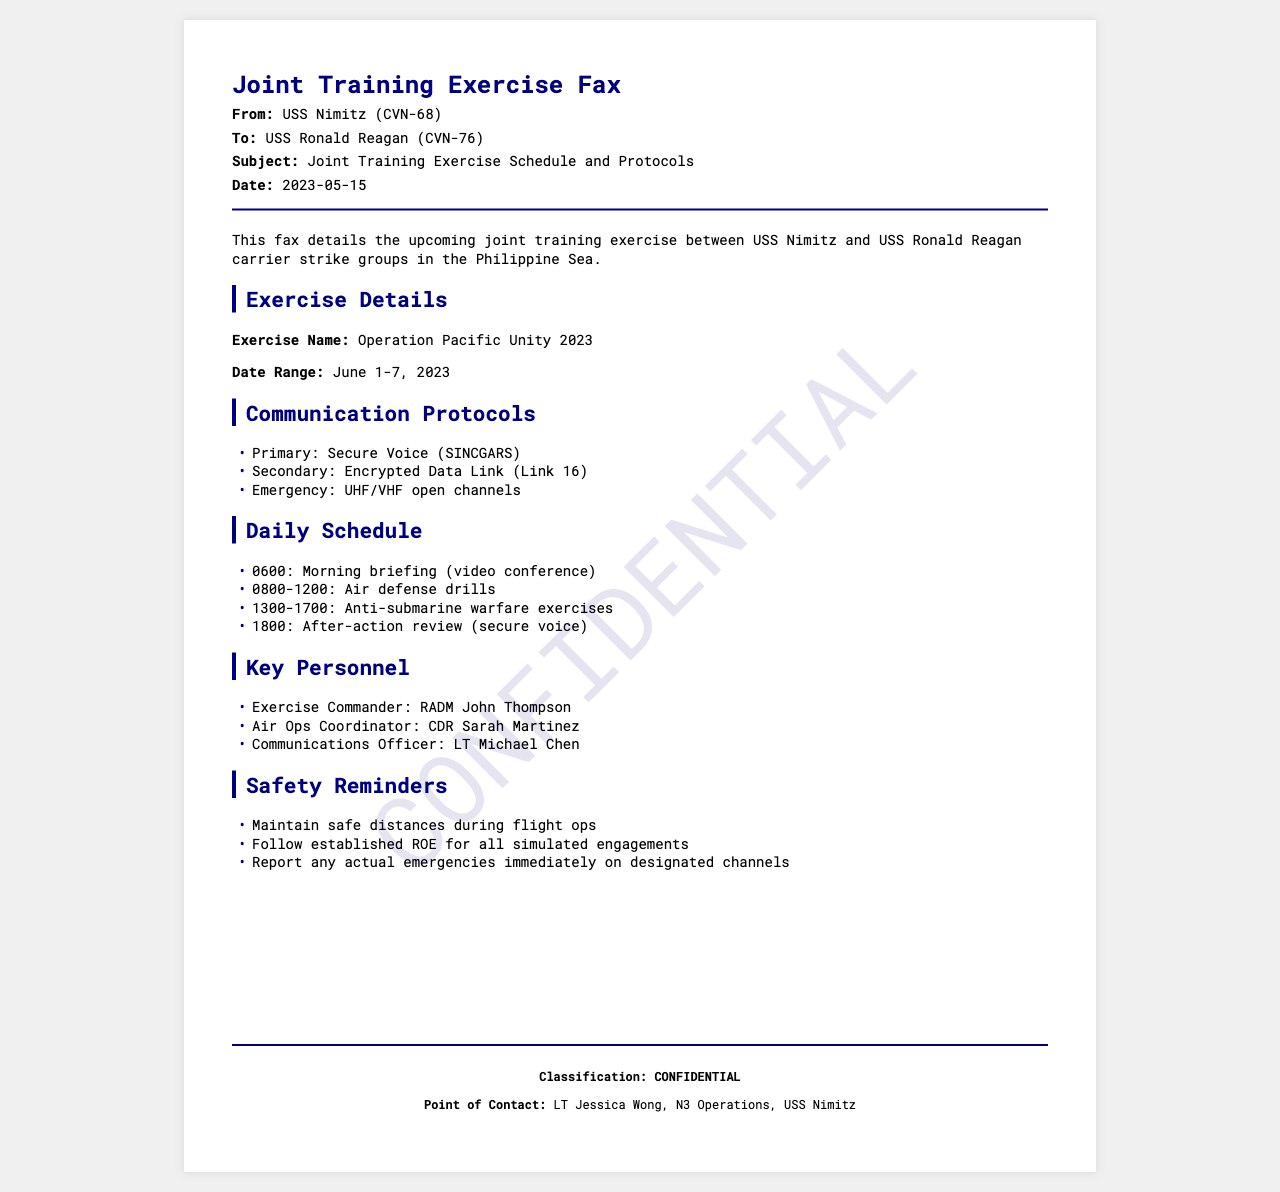What is the exercise name? The exercise name is explicitly mentioned in the document as "Operation Pacific Unity 2023."
Answer: Operation Pacific Unity 2023 What are the communication protocols' primary means? The primary communication protocol for the exercise is identified as "Secure Voice (SINCGARS)."
Answer: Secure Voice (SINCGARS) Who is the Exercise Commander? The document lists RADM John Thompson as the Exercise Commander.
Answer: RADM John Thompson What is the date range of the exercise? The date range is specified in the document as "June 1-7, 2023."
Answer: June 1-7, 2023 What time is the morning briefing scheduled? The schedule indicates that the morning briefing is at "0600."
Answer: 0600 What is the secondary communication protocol? The document states that the secondary means is "Encrypted Data Link (Link 16)."
Answer: Encrypted Data Link (Link 16) How many days does the exercise last? The duration of the exercise is 7 days, from June 1 to June 7.
Answer: 7 days What is the classification of this fax? The classification is clearly marked in the document as "CONFIDENTIAL."
Answer: CONFIDENTIAL What time does the after-action review take place? The document specifies the time for the after-action review as "1800."
Answer: 1800 